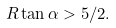<formula> <loc_0><loc_0><loc_500><loc_500>R \tan \alpha > 5 / 2 .</formula> 